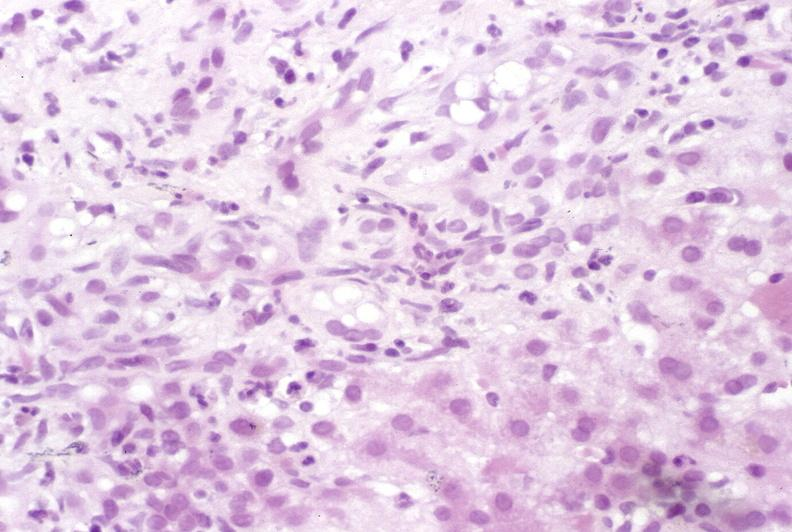s beckwith-wiedemann syndrome present?
Answer the question using a single word or phrase. No 